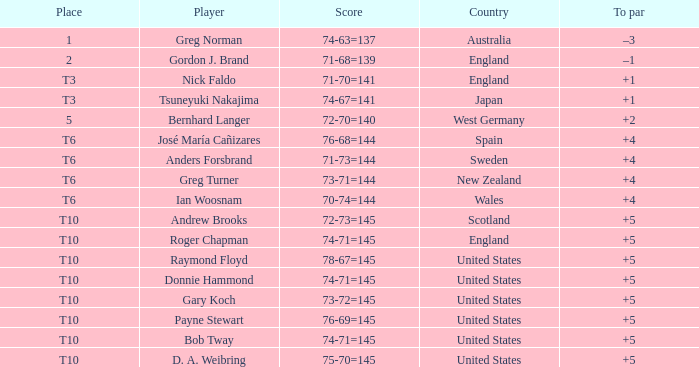What country did Raymond Floyd play for? United States. 